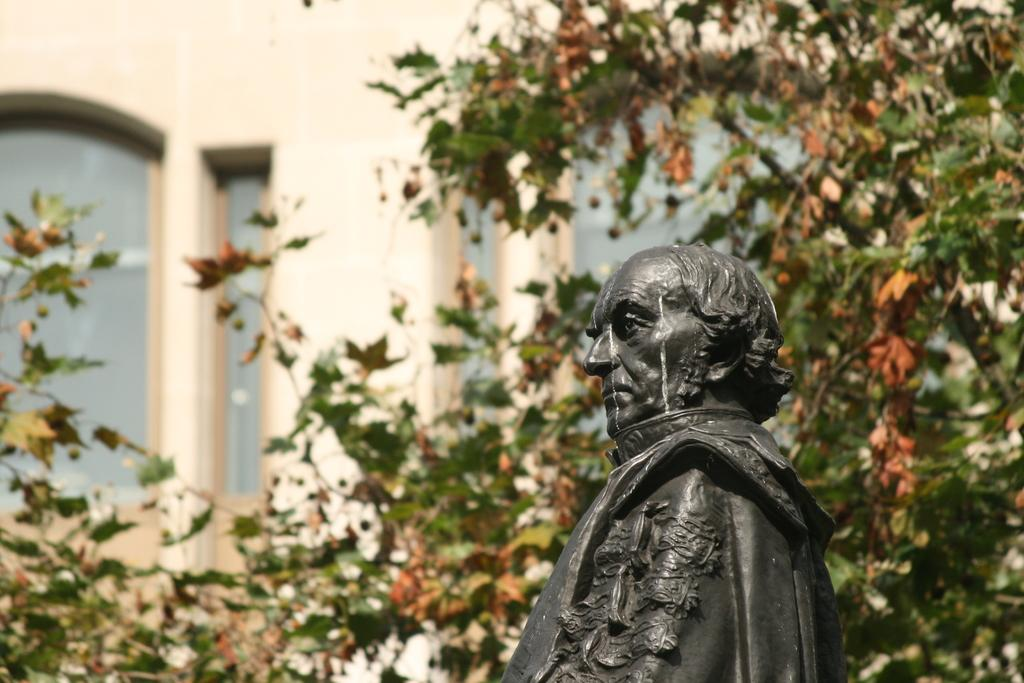What is the main subject of the image? There is a sculpture of a man in the image. What else can be seen in the image besides the sculpture? There are plants visible in the image. What type of material is used for the building wall in the image? There is a building wall with glass in the image. What type of corn is being attacked by the dad in the image? There is no dad or corn present in the image; it only features a sculpture of a man, plants, and a building wall with glass. 